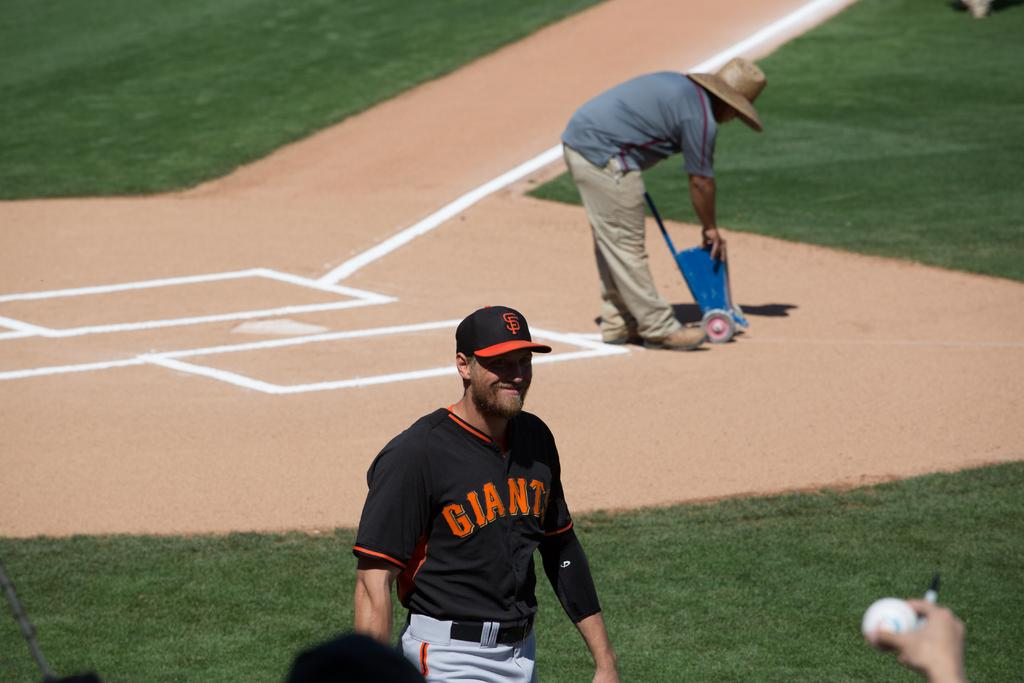<image>
Create a compact narrative representing the image presented. A baseball player whose uniform says Giants is standing on the field while a man is painting lines in the dirt. 